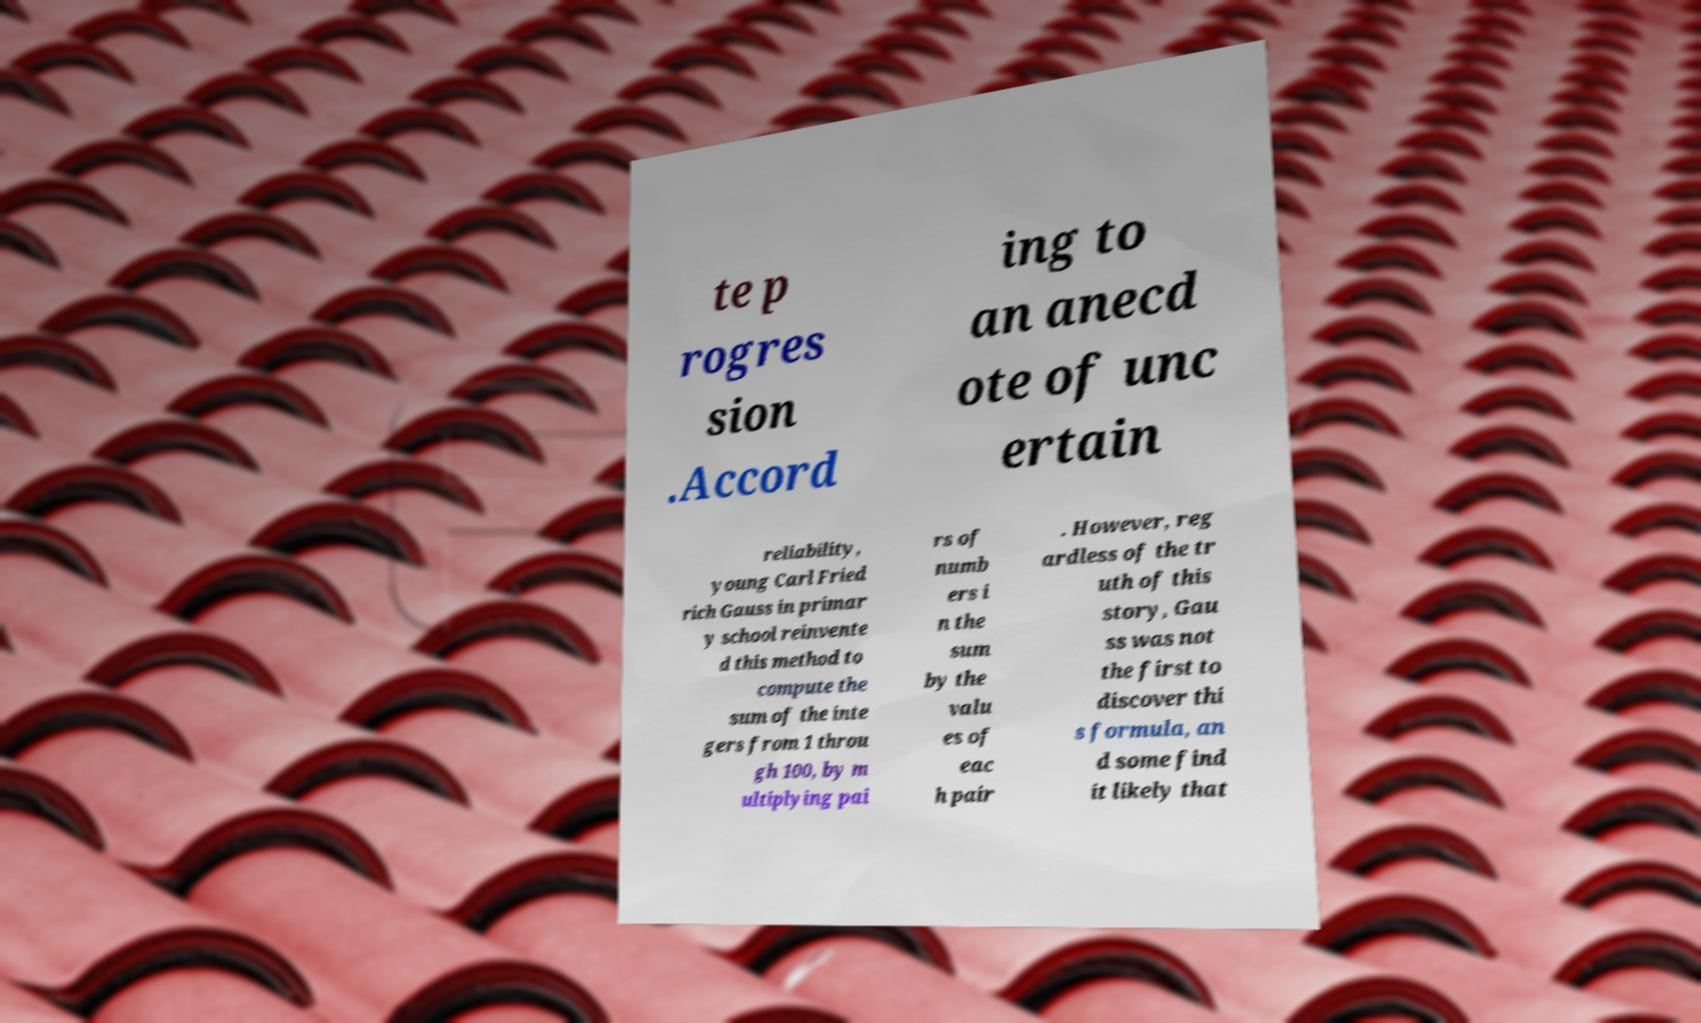What messages or text are displayed in this image? I need them in a readable, typed format. te p rogres sion .Accord ing to an anecd ote of unc ertain reliability, young Carl Fried rich Gauss in primar y school reinvente d this method to compute the sum of the inte gers from 1 throu gh 100, by m ultiplying pai rs of numb ers i n the sum by the valu es of eac h pair . However, reg ardless of the tr uth of this story, Gau ss was not the first to discover thi s formula, an d some find it likely that 